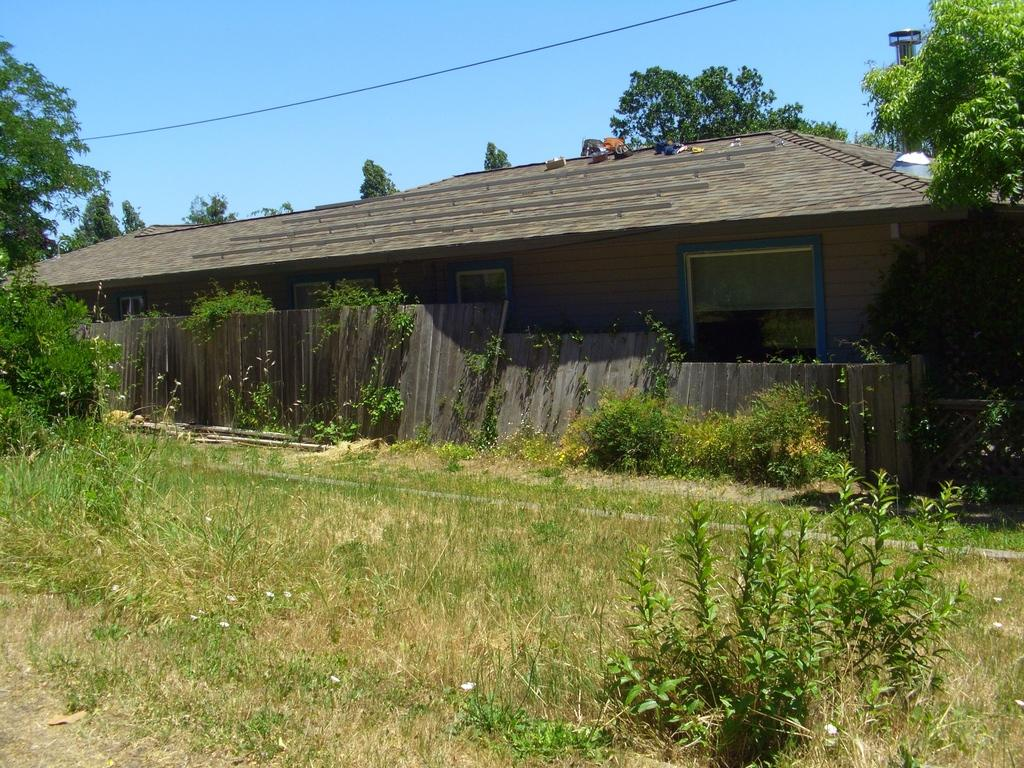What is the main structure in the center of the image? There is a shed in the center of the image. What type of vegetation is at the bottom of the image? There is grass at the bottom of the image. What other types of vegetation can be seen in the image? Plants are visible in the image. What can be seen in the background of the image? There are trees and the sky visible in the background of the image. What is the wire used for in the image? The purpose of the wire is not clear from the image. What type of barrier is present in the image? A fence is present in the image. How does the calculator blow in the wind in the image? There is no calculator present in the image, so it cannot blow in the wind. 